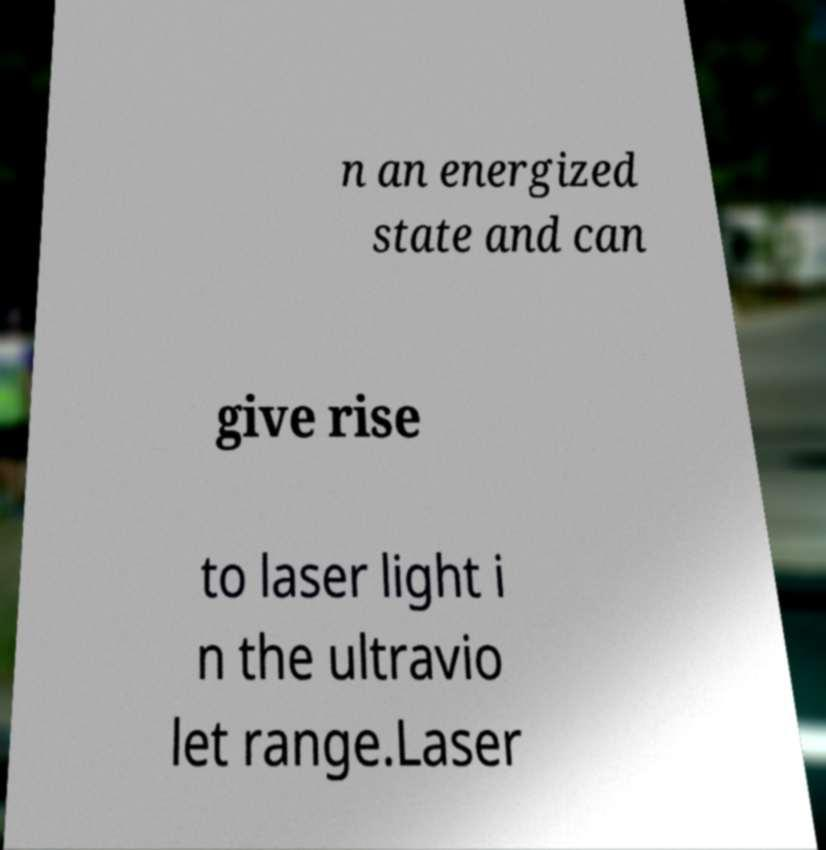I need the written content from this picture converted into text. Can you do that? n an energized state and can give rise to laser light i n the ultravio let range.Laser 